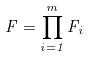<formula> <loc_0><loc_0><loc_500><loc_500>F = \prod _ { i = 1 } ^ { m } F _ { i }</formula> 